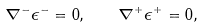Convert formula to latex. <formula><loc_0><loc_0><loc_500><loc_500>\nabla ^ { - } \epsilon ^ { - } = 0 , \quad \nabla ^ { + } \epsilon ^ { + } = 0 ,</formula> 